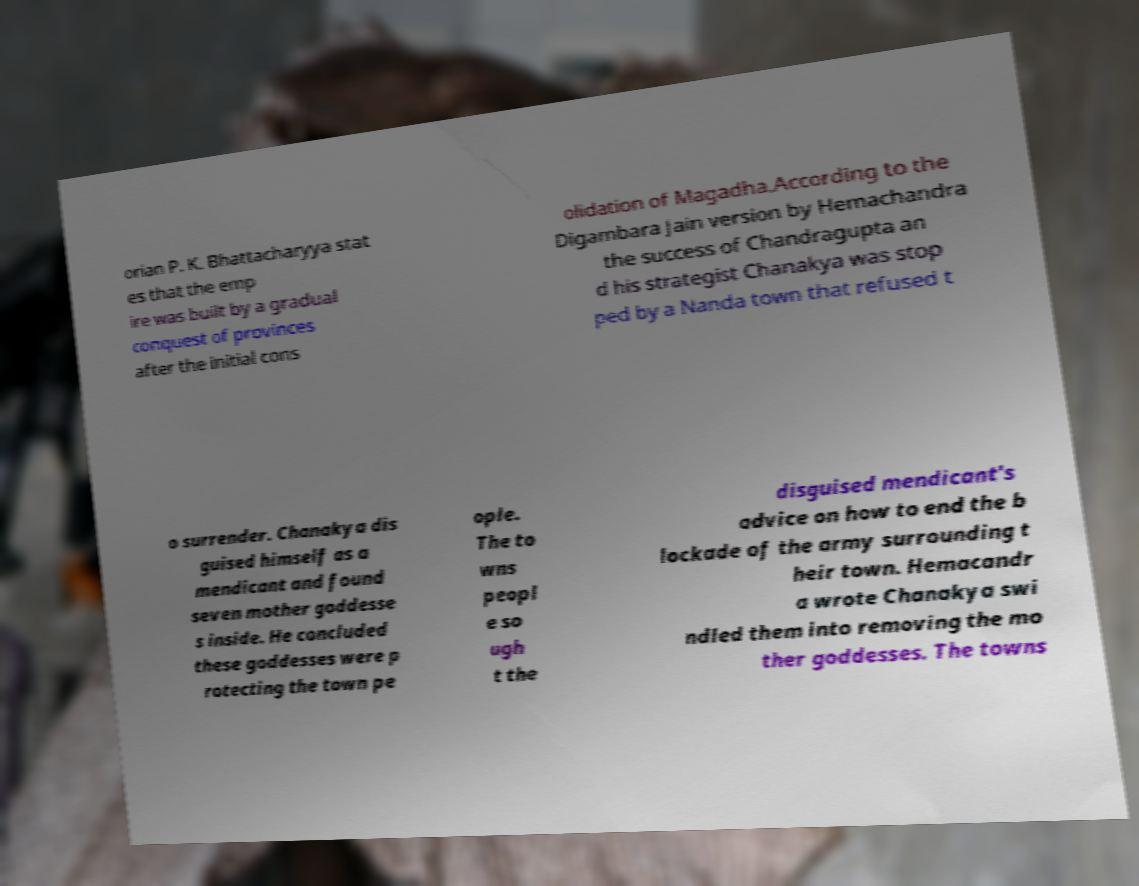Can you read and provide the text displayed in the image?This photo seems to have some interesting text. Can you extract and type it out for me? orian P. K. Bhattacharyya stat es that the emp ire was built by a gradual conquest of provinces after the initial cons olidation of Magadha.According to the Digambara Jain version by Hemachandra the success of Chandragupta an d his strategist Chanakya was stop ped by a Nanda town that refused t o surrender. Chanakya dis guised himself as a mendicant and found seven mother goddesse s inside. He concluded these goddesses were p rotecting the town pe ople. The to wns peopl e so ugh t the disguised mendicant's advice on how to end the b lockade of the army surrounding t heir town. Hemacandr a wrote Chanakya swi ndled them into removing the mo ther goddesses. The towns 